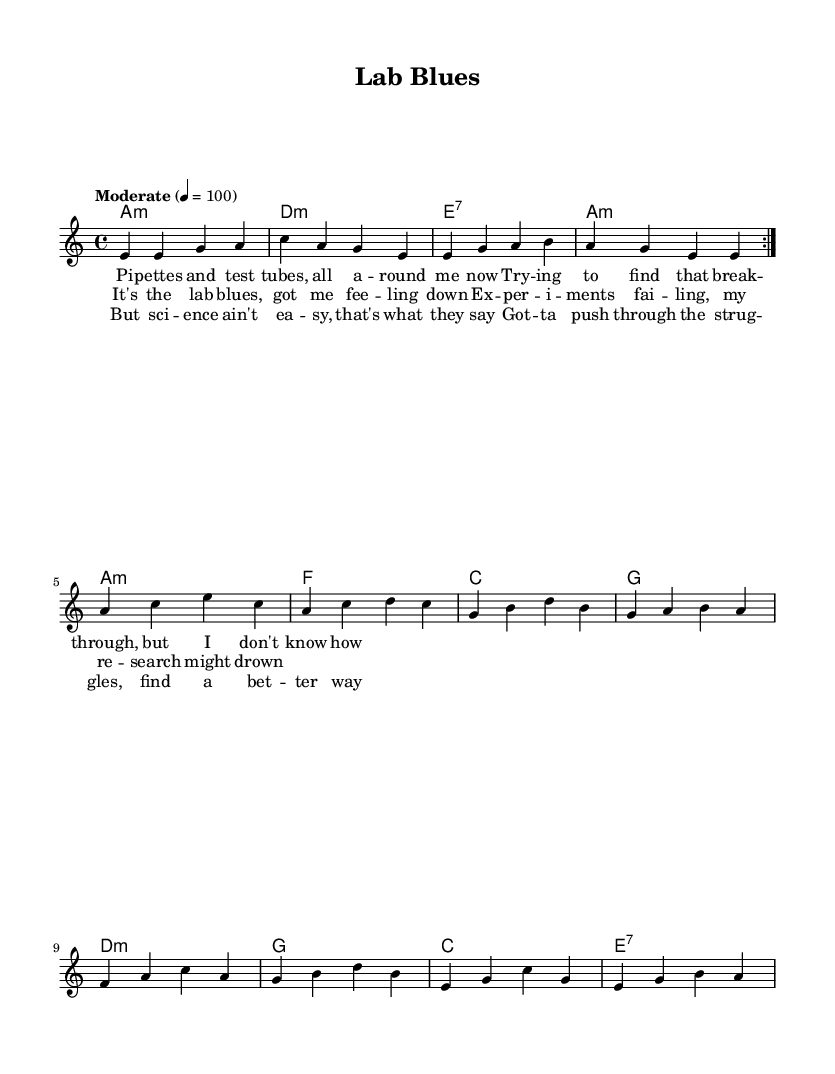What is the key signature of this music? The key signature is A minor, indicated by the presence of no sharps or flats in the key signature area.
Answer: A minor What is the time signature of this music? The time signature is 4/4, which means there are four beats in each measure and a quarter note receives one beat. This can be identified at the beginning of the music.
Answer: 4/4 What is the tempo marking for this piece? The tempo marking is "Moderate" with a speed of 100 beats per minute, indicated at the beginning of the score right after the time signature.
Answer: Moderate 4 = 100 How many measures are in the verse? The verse consists of 8 measures, as counted from the melody section and including the repeats. Each section of lyrics is allotted to a specific measure of melody, confirming a total of 8 measures.
Answer: 8 What is the primary theme of the lyrics? The primary theme revolves around the struggles and challenges faced during experiments in a laboratory setting, as indicated by the reference to "test tubes" and "experiments failing."
Answer: Challenges in a laboratory What chord follows the A minor chord in the harmony? The chord following the A minor in the harmony section is D minor, which is determined by analyzing the chord changes in the harmonic progression represented in the score.
Answer: D minor How is the bridge differentiated from the verses? The bridge is differentiated by the change in lyrics and melody, which contrasts the initial feelings expressed in the verses and introduces a new message about perseverance in science. It is also structurally placed in a distinct section of the music.
Answer: New lyrics and melody contrast 